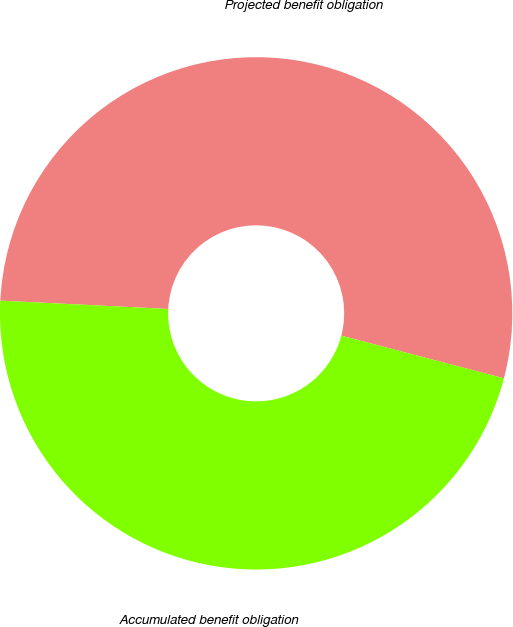<chart> <loc_0><loc_0><loc_500><loc_500><pie_chart><fcel>Projected benefit obligation<fcel>Accumulated benefit obligation<nl><fcel>53.29%<fcel>46.71%<nl></chart> 